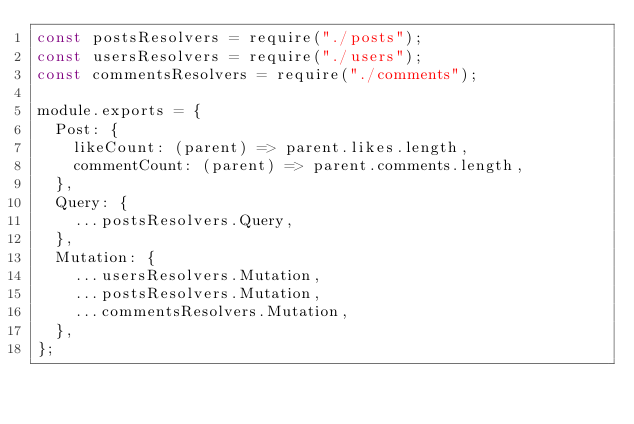Convert code to text. <code><loc_0><loc_0><loc_500><loc_500><_JavaScript_>const postsResolvers = require("./posts");
const usersResolvers = require("./users");
const commentsResolvers = require("./comments");

module.exports = {
  Post: {
    likeCount: (parent) => parent.likes.length,
    commentCount: (parent) => parent.comments.length,
  },
  Query: {
    ...postsResolvers.Query,
  },
  Mutation: {
    ...usersResolvers.Mutation,
    ...postsResolvers.Mutation,
    ...commentsResolvers.Mutation,
  },
};
</code> 